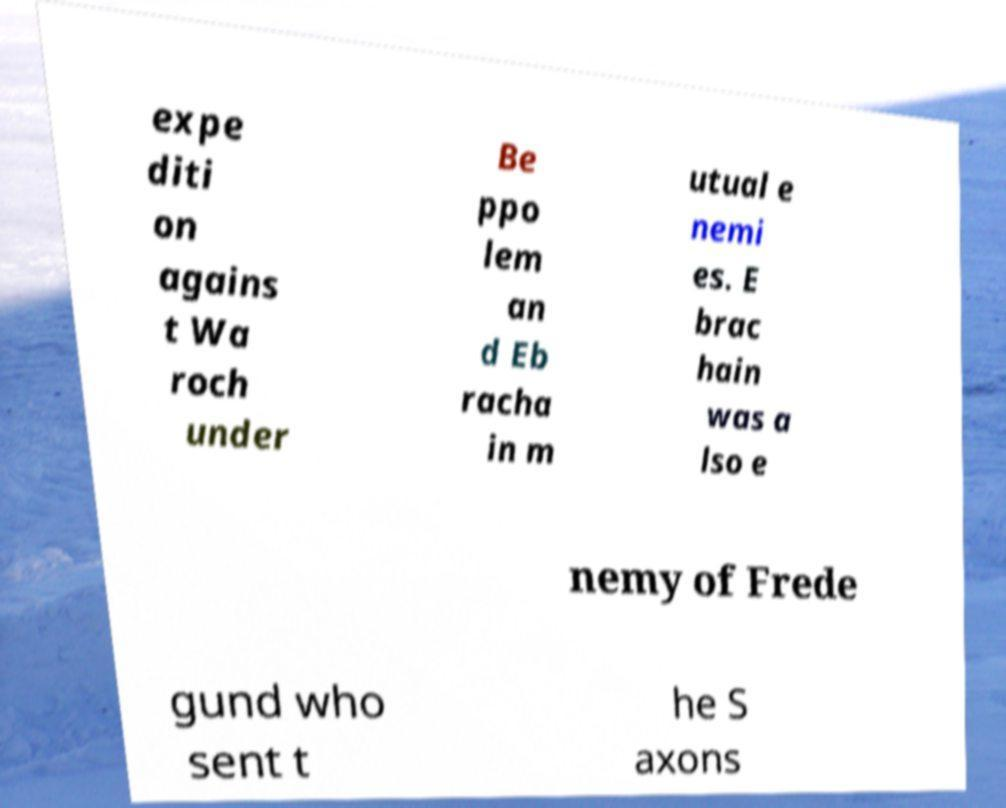Can you read and provide the text displayed in the image?This photo seems to have some interesting text. Can you extract and type it out for me? expe diti on agains t Wa roch under Be ppo lem an d Eb racha in m utual e nemi es. E brac hain was a lso e nemy of Frede gund who sent t he S axons 